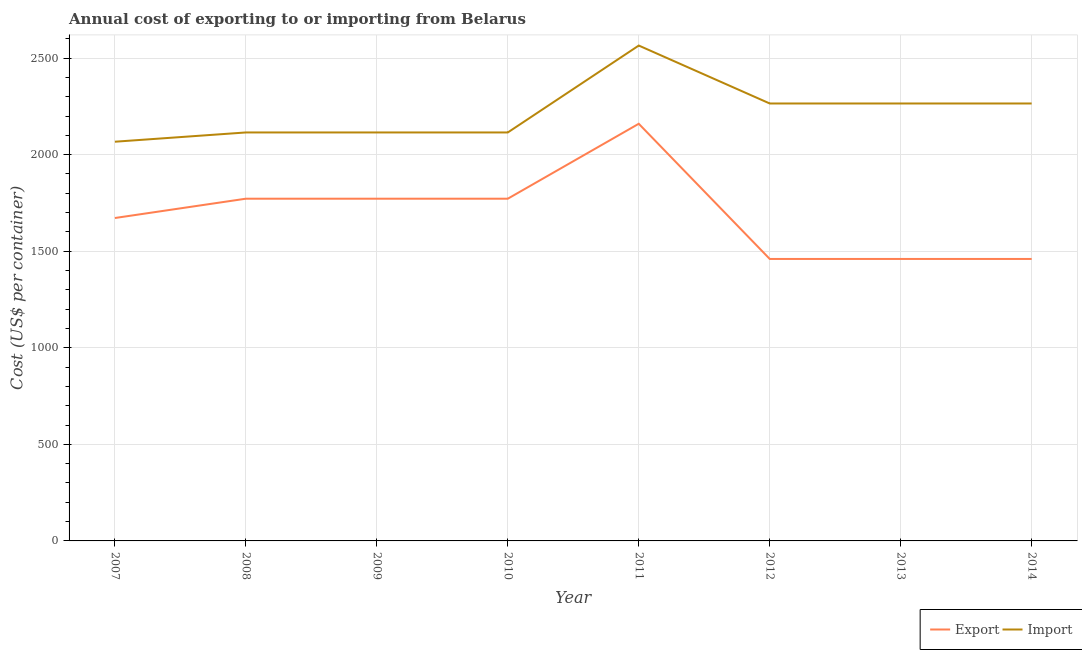How many different coloured lines are there?
Ensure brevity in your answer.  2. Does the line corresponding to export cost intersect with the line corresponding to import cost?
Offer a very short reply. No. Is the number of lines equal to the number of legend labels?
Make the answer very short. Yes. What is the import cost in 2011?
Your response must be concise. 2565. Across all years, what is the maximum import cost?
Your answer should be compact. 2565. Across all years, what is the minimum import cost?
Your response must be concise. 2067. In which year was the export cost minimum?
Ensure brevity in your answer.  2012. What is the total import cost in the graph?
Give a very brief answer. 1.78e+04. What is the difference between the import cost in 2010 and that in 2013?
Your answer should be compact. -150. What is the difference between the export cost in 2012 and the import cost in 2009?
Provide a short and direct response. -655. What is the average import cost per year?
Offer a terse response. 2221.5. In the year 2013, what is the difference between the import cost and export cost?
Offer a very short reply. 805. What is the ratio of the export cost in 2007 to that in 2008?
Provide a short and direct response. 0.94. Is the difference between the export cost in 2009 and 2014 greater than the difference between the import cost in 2009 and 2014?
Your answer should be very brief. Yes. What is the difference between the highest and the second highest import cost?
Offer a very short reply. 300. What is the difference between the highest and the lowest export cost?
Provide a short and direct response. 700. Is the sum of the export cost in 2009 and 2014 greater than the maximum import cost across all years?
Make the answer very short. Yes. Does the export cost monotonically increase over the years?
Ensure brevity in your answer.  No. Is the export cost strictly greater than the import cost over the years?
Offer a terse response. No. Is the export cost strictly less than the import cost over the years?
Ensure brevity in your answer.  Yes. How many lines are there?
Your answer should be compact. 2. How many years are there in the graph?
Give a very brief answer. 8. What is the difference between two consecutive major ticks on the Y-axis?
Provide a succinct answer. 500. Does the graph contain any zero values?
Keep it short and to the point. No. Does the graph contain grids?
Offer a terse response. Yes. Where does the legend appear in the graph?
Your response must be concise. Bottom right. How many legend labels are there?
Give a very brief answer. 2. What is the title of the graph?
Keep it short and to the point. Annual cost of exporting to or importing from Belarus. Does "Highest 10% of population" appear as one of the legend labels in the graph?
Ensure brevity in your answer.  No. What is the label or title of the X-axis?
Your answer should be very brief. Year. What is the label or title of the Y-axis?
Your response must be concise. Cost (US$ per container). What is the Cost (US$ per container) of Export in 2007?
Offer a terse response. 1672. What is the Cost (US$ per container) of Import in 2007?
Give a very brief answer. 2067. What is the Cost (US$ per container) of Export in 2008?
Ensure brevity in your answer.  1772. What is the Cost (US$ per container) of Import in 2008?
Keep it short and to the point. 2115. What is the Cost (US$ per container) of Export in 2009?
Provide a succinct answer. 1772. What is the Cost (US$ per container) in Import in 2009?
Make the answer very short. 2115. What is the Cost (US$ per container) of Export in 2010?
Your answer should be very brief. 1772. What is the Cost (US$ per container) in Import in 2010?
Your answer should be very brief. 2115. What is the Cost (US$ per container) of Export in 2011?
Offer a very short reply. 2160. What is the Cost (US$ per container) of Import in 2011?
Keep it short and to the point. 2565. What is the Cost (US$ per container) in Export in 2012?
Your response must be concise. 1460. What is the Cost (US$ per container) of Import in 2012?
Your answer should be very brief. 2265. What is the Cost (US$ per container) in Export in 2013?
Provide a succinct answer. 1460. What is the Cost (US$ per container) in Import in 2013?
Keep it short and to the point. 2265. What is the Cost (US$ per container) of Export in 2014?
Ensure brevity in your answer.  1460. What is the Cost (US$ per container) of Import in 2014?
Offer a terse response. 2265. Across all years, what is the maximum Cost (US$ per container) of Export?
Make the answer very short. 2160. Across all years, what is the maximum Cost (US$ per container) in Import?
Offer a terse response. 2565. Across all years, what is the minimum Cost (US$ per container) of Export?
Keep it short and to the point. 1460. Across all years, what is the minimum Cost (US$ per container) in Import?
Make the answer very short. 2067. What is the total Cost (US$ per container) of Export in the graph?
Offer a very short reply. 1.35e+04. What is the total Cost (US$ per container) in Import in the graph?
Give a very brief answer. 1.78e+04. What is the difference between the Cost (US$ per container) in Export in 2007 and that in 2008?
Your answer should be very brief. -100. What is the difference between the Cost (US$ per container) in Import in 2007 and that in 2008?
Offer a very short reply. -48. What is the difference between the Cost (US$ per container) in Export in 2007 and that in 2009?
Provide a succinct answer. -100. What is the difference between the Cost (US$ per container) in Import in 2007 and that in 2009?
Offer a terse response. -48. What is the difference between the Cost (US$ per container) in Export in 2007 and that in 2010?
Make the answer very short. -100. What is the difference between the Cost (US$ per container) of Import in 2007 and that in 2010?
Keep it short and to the point. -48. What is the difference between the Cost (US$ per container) of Export in 2007 and that in 2011?
Provide a succinct answer. -488. What is the difference between the Cost (US$ per container) of Import in 2007 and that in 2011?
Provide a short and direct response. -498. What is the difference between the Cost (US$ per container) in Export in 2007 and that in 2012?
Offer a terse response. 212. What is the difference between the Cost (US$ per container) in Import in 2007 and that in 2012?
Offer a terse response. -198. What is the difference between the Cost (US$ per container) of Export in 2007 and that in 2013?
Your answer should be compact. 212. What is the difference between the Cost (US$ per container) in Import in 2007 and that in 2013?
Provide a succinct answer. -198. What is the difference between the Cost (US$ per container) in Export in 2007 and that in 2014?
Provide a short and direct response. 212. What is the difference between the Cost (US$ per container) in Import in 2007 and that in 2014?
Make the answer very short. -198. What is the difference between the Cost (US$ per container) of Import in 2008 and that in 2009?
Provide a short and direct response. 0. What is the difference between the Cost (US$ per container) of Export in 2008 and that in 2010?
Your response must be concise. 0. What is the difference between the Cost (US$ per container) in Export in 2008 and that in 2011?
Give a very brief answer. -388. What is the difference between the Cost (US$ per container) in Import in 2008 and that in 2011?
Provide a short and direct response. -450. What is the difference between the Cost (US$ per container) in Export in 2008 and that in 2012?
Your answer should be very brief. 312. What is the difference between the Cost (US$ per container) of Import in 2008 and that in 2012?
Your answer should be compact. -150. What is the difference between the Cost (US$ per container) in Export in 2008 and that in 2013?
Your answer should be very brief. 312. What is the difference between the Cost (US$ per container) in Import in 2008 and that in 2013?
Offer a terse response. -150. What is the difference between the Cost (US$ per container) in Export in 2008 and that in 2014?
Offer a terse response. 312. What is the difference between the Cost (US$ per container) in Import in 2008 and that in 2014?
Your answer should be very brief. -150. What is the difference between the Cost (US$ per container) in Export in 2009 and that in 2010?
Keep it short and to the point. 0. What is the difference between the Cost (US$ per container) of Import in 2009 and that in 2010?
Provide a short and direct response. 0. What is the difference between the Cost (US$ per container) of Export in 2009 and that in 2011?
Offer a very short reply. -388. What is the difference between the Cost (US$ per container) in Import in 2009 and that in 2011?
Provide a succinct answer. -450. What is the difference between the Cost (US$ per container) in Export in 2009 and that in 2012?
Make the answer very short. 312. What is the difference between the Cost (US$ per container) in Import in 2009 and that in 2012?
Offer a very short reply. -150. What is the difference between the Cost (US$ per container) of Export in 2009 and that in 2013?
Keep it short and to the point. 312. What is the difference between the Cost (US$ per container) in Import in 2009 and that in 2013?
Offer a terse response. -150. What is the difference between the Cost (US$ per container) of Export in 2009 and that in 2014?
Your answer should be compact. 312. What is the difference between the Cost (US$ per container) in Import in 2009 and that in 2014?
Your response must be concise. -150. What is the difference between the Cost (US$ per container) in Export in 2010 and that in 2011?
Provide a short and direct response. -388. What is the difference between the Cost (US$ per container) of Import in 2010 and that in 2011?
Give a very brief answer. -450. What is the difference between the Cost (US$ per container) of Export in 2010 and that in 2012?
Your answer should be compact. 312. What is the difference between the Cost (US$ per container) of Import in 2010 and that in 2012?
Give a very brief answer. -150. What is the difference between the Cost (US$ per container) of Export in 2010 and that in 2013?
Keep it short and to the point. 312. What is the difference between the Cost (US$ per container) in Import in 2010 and that in 2013?
Your answer should be very brief. -150. What is the difference between the Cost (US$ per container) of Export in 2010 and that in 2014?
Keep it short and to the point. 312. What is the difference between the Cost (US$ per container) of Import in 2010 and that in 2014?
Your answer should be very brief. -150. What is the difference between the Cost (US$ per container) in Export in 2011 and that in 2012?
Make the answer very short. 700. What is the difference between the Cost (US$ per container) of Import in 2011 and that in 2012?
Provide a succinct answer. 300. What is the difference between the Cost (US$ per container) of Export in 2011 and that in 2013?
Give a very brief answer. 700. What is the difference between the Cost (US$ per container) in Import in 2011 and that in 2013?
Give a very brief answer. 300. What is the difference between the Cost (US$ per container) in Export in 2011 and that in 2014?
Provide a short and direct response. 700. What is the difference between the Cost (US$ per container) of Import in 2011 and that in 2014?
Provide a short and direct response. 300. What is the difference between the Cost (US$ per container) of Import in 2012 and that in 2013?
Your response must be concise. 0. What is the difference between the Cost (US$ per container) of Export in 2007 and the Cost (US$ per container) of Import in 2008?
Provide a succinct answer. -443. What is the difference between the Cost (US$ per container) of Export in 2007 and the Cost (US$ per container) of Import in 2009?
Ensure brevity in your answer.  -443. What is the difference between the Cost (US$ per container) in Export in 2007 and the Cost (US$ per container) in Import in 2010?
Offer a terse response. -443. What is the difference between the Cost (US$ per container) in Export in 2007 and the Cost (US$ per container) in Import in 2011?
Provide a short and direct response. -893. What is the difference between the Cost (US$ per container) in Export in 2007 and the Cost (US$ per container) in Import in 2012?
Give a very brief answer. -593. What is the difference between the Cost (US$ per container) of Export in 2007 and the Cost (US$ per container) of Import in 2013?
Keep it short and to the point. -593. What is the difference between the Cost (US$ per container) of Export in 2007 and the Cost (US$ per container) of Import in 2014?
Provide a short and direct response. -593. What is the difference between the Cost (US$ per container) of Export in 2008 and the Cost (US$ per container) of Import in 2009?
Your answer should be very brief. -343. What is the difference between the Cost (US$ per container) of Export in 2008 and the Cost (US$ per container) of Import in 2010?
Provide a succinct answer. -343. What is the difference between the Cost (US$ per container) of Export in 2008 and the Cost (US$ per container) of Import in 2011?
Offer a very short reply. -793. What is the difference between the Cost (US$ per container) in Export in 2008 and the Cost (US$ per container) in Import in 2012?
Provide a succinct answer. -493. What is the difference between the Cost (US$ per container) of Export in 2008 and the Cost (US$ per container) of Import in 2013?
Your response must be concise. -493. What is the difference between the Cost (US$ per container) in Export in 2008 and the Cost (US$ per container) in Import in 2014?
Keep it short and to the point. -493. What is the difference between the Cost (US$ per container) in Export in 2009 and the Cost (US$ per container) in Import in 2010?
Keep it short and to the point. -343. What is the difference between the Cost (US$ per container) in Export in 2009 and the Cost (US$ per container) in Import in 2011?
Your answer should be compact. -793. What is the difference between the Cost (US$ per container) in Export in 2009 and the Cost (US$ per container) in Import in 2012?
Your response must be concise. -493. What is the difference between the Cost (US$ per container) in Export in 2009 and the Cost (US$ per container) in Import in 2013?
Your response must be concise. -493. What is the difference between the Cost (US$ per container) in Export in 2009 and the Cost (US$ per container) in Import in 2014?
Give a very brief answer. -493. What is the difference between the Cost (US$ per container) in Export in 2010 and the Cost (US$ per container) in Import in 2011?
Offer a very short reply. -793. What is the difference between the Cost (US$ per container) of Export in 2010 and the Cost (US$ per container) of Import in 2012?
Offer a terse response. -493. What is the difference between the Cost (US$ per container) in Export in 2010 and the Cost (US$ per container) in Import in 2013?
Your answer should be very brief. -493. What is the difference between the Cost (US$ per container) of Export in 2010 and the Cost (US$ per container) of Import in 2014?
Offer a terse response. -493. What is the difference between the Cost (US$ per container) in Export in 2011 and the Cost (US$ per container) in Import in 2012?
Provide a succinct answer. -105. What is the difference between the Cost (US$ per container) of Export in 2011 and the Cost (US$ per container) of Import in 2013?
Offer a very short reply. -105. What is the difference between the Cost (US$ per container) of Export in 2011 and the Cost (US$ per container) of Import in 2014?
Keep it short and to the point. -105. What is the difference between the Cost (US$ per container) in Export in 2012 and the Cost (US$ per container) in Import in 2013?
Offer a terse response. -805. What is the difference between the Cost (US$ per container) in Export in 2012 and the Cost (US$ per container) in Import in 2014?
Your answer should be compact. -805. What is the difference between the Cost (US$ per container) of Export in 2013 and the Cost (US$ per container) of Import in 2014?
Your answer should be very brief. -805. What is the average Cost (US$ per container) of Export per year?
Ensure brevity in your answer.  1691. What is the average Cost (US$ per container) of Import per year?
Your answer should be very brief. 2221.5. In the year 2007, what is the difference between the Cost (US$ per container) of Export and Cost (US$ per container) of Import?
Ensure brevity in your answer.  -395. In the year 2008, what is the difference between the Cost (US$ per container) of Export and Cost (US$ per container) of Import?
Give a very brief answer. -343. In the year 2009, what is the difference between the Cost (US$ per container) of Export and Cost (US$ per container) of Import?
Your response must be concise. -343. In the year 2010, what is the difference between the Cost (US$ per container) of Export and Cost (US$ per container) of Import?
Make the answer very short. -343. In the year 2011, what is the difference between the Cost (US$ per container) in Export and Cost (US$ per container) in Import?
Provide a succinct answer. -405. In the year 2012, what is the difference between the Cost (US$ per container) in Export and Cost (US$ per container) in Import?
Your response must be concise. -805. In the year 2013, what is the difference between the Cost (US$ per container) in Export and Cost (US$ per container) in Import?
Your answer should be very brief. -805. In the year 2014, what is the difference between the Cost (US$ per container) of Export and Cost (US$ per container) of Import?
Your answer should be very brief. -805. What is the ratio of the Cost (US$ per container) in Export in 2007 to that in 2008?
Keep it short and to the point. 0.94. What is the ratio of the Cost (US$ per container) of Import in 2007 to that in 2008?
Keep it short and to the point. 0.98. What is the ratio of the Cost (US$ per container) of Export in 2007 to that in 2009?
Your answer should be compact. 0.94. What is the ratio of the Cost (US$ per container) in Import in 2007 to that in 2009?
Keep it short and to the point. 0.98. What is the ratio of the Cost (US$ per container) in Export in 2007 to that in 2010?
Ensure brevity in your answer.  0.94. What is the ratio of the Cost (US$ per container) in Import in 2007 to that in 2010?
Your response must be concise. 0.98. What is the ratio of the Cost (US$ per container) in Export in 2007 to that in 2011?
Ensure brevity in your answer.  0.77. What is the ratio of the Cost (US$ per container) of Import in 2007 to that in 2011?
Your answer should be very brief. 0.81. What is the ratio of the Cost (US$ per container) in Export in 2007 to that in 2012?
Provide a succinct answer. 1.15. What is the ratio of the Cost (US$ per container) in Import in 2007 to that in 2012?
Your answer should be very brief. 0.91. What is the ratio of the Cost (US$ per container) in Export in 2007 to that in 2013?
Keep it short and to the point. 1.15. What is the ratio of the Cost (US$ per container) of Import in 2007 to that in 2013?
Offer a very short reply. 0.91. What is the ratio of the Cost (US$ per container) in Export in 2007 to that in 2014?
Give a very brief answer. 1.15. What is the ratio of the Cost (US$ per container) of Import in 2007 to that in 2014?
Give a very brief answer. 0.91. What is the ratio of the Cost (US$ per container) of Import in 2008 to that in 2009?
Keep it short and to the point. 1. What is the ratio of the Cost (US$ per container) in Export in 2008 to that in 2010?
Make the answer very short. 1. What is the ratio of the Cost (US$ per container) in Export in 2008 to that in 2011?
Provide a short and direct response. 0.82. What is the ratio of the Cost (US$ per container) in Import in 2008 to that in 2011?
Keep it short and to the point. 0.82. What is the ratio of the Cost (US$ per container) in Export in 2008 to that in 2012?
Your answer should be compact. 1.21. What is the ratio of the Cost (US$ per container) in Import in 2008 to that in 2012?
Offer a terse response. 0.93. What is the ratio of the Cost (US$ per container) in Export in 2008 to that in 2013?
Provide a short and direct response. 1.21. What is the ratio of the Cost (US$ per container) in Import in 2008 to that in 2013?
Give a very brief answer. 0.93. What is the ratio of the Cost (US$ per container) of Export in 2008 to that in 2014?
Your answer should be compact. 1.21. What is the ratio of the Cost (US$ per container) of Import in 2008 to that in 2014?
Provide a succinct answer. 0.93. What is the ratio of the Cost (US$ per container) in Export in 2009 to that in 2011?
Your answer should be very brief. 0.82. What is the ratio of the Cost (US$ per container) of Import in 2009 to that in 2011?
Provide a succinct answer. 0.82. What is the ratio of the Cost (US$ per container) in Export in 2009 to that in 2012?
Provide a succinct answer. 1.21. What is the ratio of the Cost (US$ per container) in Import in 2009 to that in 2012?
Offer a terse response. 0.93. What is the ratio of the Cost (US$ per container) of Export in 2009 to that in 2013?
Your answer should be compact. 1.21. What is the ratio of the Cost (US$ per container) of Import in 2009 to that in 2013?
Your answer should be very brief. 0.93. What is the ratio of the Cost (US$ per container) in Export in 2009 to that in 2014?
Offer a terse response. 1.21. What is the ratio of the Cost (US$ per container) of Import in 2009 to that in 2014?
Provide a short and direct response. 0.93. What is the ratio of the Cost (US$ per container) in Export in 2010 to that in 2011?
Offer a very short reply. 0.82. What is the ratio of the Cost (US$ per container) in Import in 2010 to that in 2011?
Make the answer very short. 0.82. What is the ratio of the Cost (US$ per container) in Export in 2010 to that in 2012?
Provide a short and direct response. 1.21. What is the ratio of the Cost (US$ per container) in Import in 2010 to that in 2012?
Your answer should be very brief. 0.93. What is the ratio of the Cost (US$ per container) of Export in 2010 to that in 2013?
Make the answer very short. 1.21. What is the ratio of the Cost (US$ per container) of Import in 2010 to that in 2013?
Offer a terse response. 0.93. What is the ratio of the Cost (US$ per container) of Export in 2010 to that in 2014?
Provide a short and direct response. 1.21. What is the ratio of the Cost (US$ per container) of Import in 2010 to that in 2014?
Provide a succinct answer. 0.93. What is the ratio of the Cost (US$ per container) in Export in 2011 to that in 2012?
Give a very brief answer. 1.48. What is the ratio of the Cost (US$ per container) of Import in 2011 to that in 2012?
Your answer should be compact. 1.13. What is the ratio of the Cost (US$ per container) of Export in 2011 to that in 2013?
Ensure brevity in your answer.  1.48. What is the ratio of the Cost (US$ per container) of Import in 2011 to that in 2013?
Give a very brief answer. 1.13. What is the ratio of the Cost (US$ per container) of Export in 2011 to that in 2014?
Give a very brief answer. 1.48. What is the ratio of the Cost (US$ per container) in Import in 2011 to that in 2014?
Give a very brief answer. 1.13. What is the ratio of the Cost (US$ per container) of Export in 2012 to that in 2013?
Give a very brief answer. 1. What is the ratio of the Cost (US$ per container) in Import in 2012 to that in 2013?
Provide a short and direct response. 1. What is the ratio of the Cost (US$ per container) in Export in 2012 to that in 2014?
Offer a very short reply. 1. What is the ratio of the Cost (US$ per container) of Import in 2013 to that in 2014?
Offer a terse response. 1. What is the difference between the highest and the second highest Cost (US$ per container) in Export?
Provide a succinct answer. 388. What is the difference between the highest and the second highest Cost (US$ per container) of Import?
Give a very brief answer. 300. What is the difference between the highest and the lowest Cost (US$ per container) of Export?
Provide a short and direct response. 700. What is the difference between the highest and the lowest Cost (US$ per container) of Import?
Your answer should be very brief. 498. 